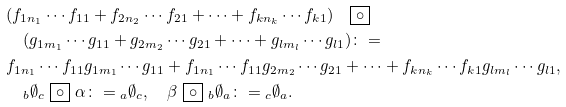Convert formula to latex. <formula><loc_0><loc_0><loc_500><loc_500>& ( f _ { 1 n _ { 1 } } \cdots f _ { 1 1 } + f _ { 2 n _ { 2 } } \cdots f _ { 2 1 } + \dots + f _ { k n _ { k } } \cdots f _ { k 1 } ) \quad \boxed { \circ } \\ & \quad ( g _ { 1 m _ { 1 } } \cdots g _ { 1 1 } + g _ { 2 m _ { 2 } } \cdots g _ { 2 1 } + \dots + g _ { l m _ { l } } \cdots g _ { l 1 } ) \colon = \\ & f _ { 1 n _ { 1 } } \cdots f _ { 1 1 } g _ { 1 m _ { 1 } } \cdots g _ { 1 1 } + f _ { 1 n _ { 1 } } \cdots f _ { 1 1 } g _ { 2 m _ { 2 } } \cdots g _ { 2 1 } + \dots + f _ { k n _ { k } } \cdots f _ { k 1 } g _ { l m _ { l } } \cdots g _ { l 1 } , \\ & \quad { _ { b } } \emptyset _ { c } \ \boxed { \circ } \ \alpha \colon = { _ { a } } \emptyset _ { c } , \quad \beta \ \boxed { \circ } \ { _ { b } } \emptyset _ { a } \colon = { _ { c } } \emptyset _ { a } .</formula> 